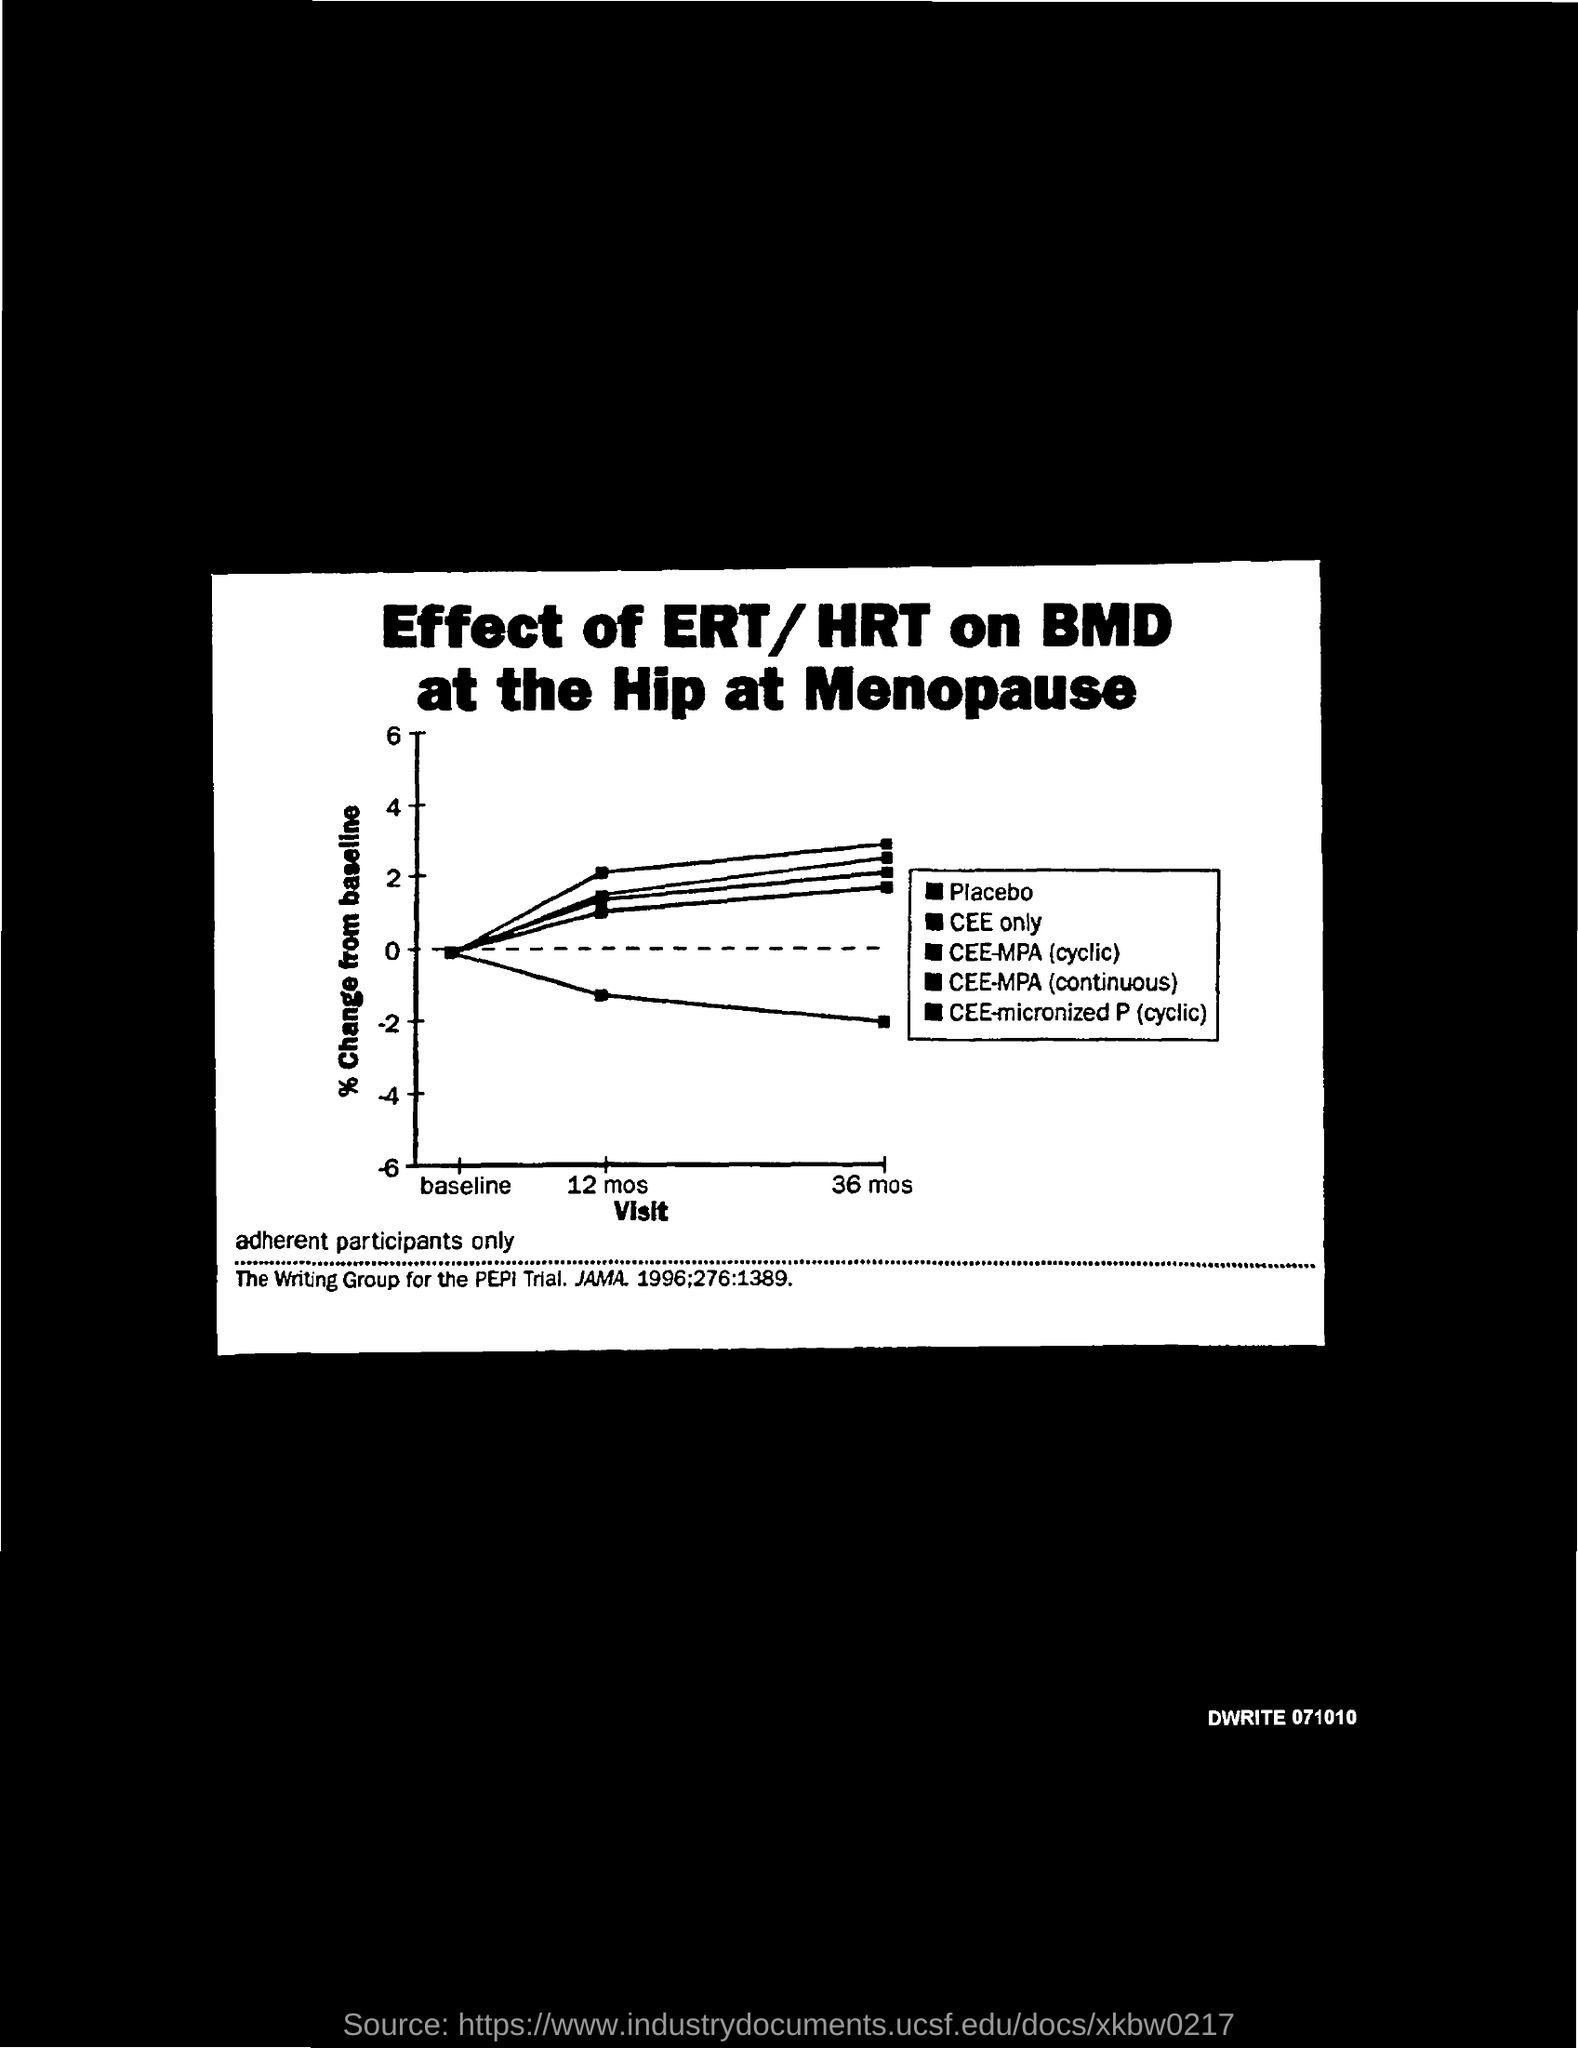What is the Document Number?
Your answer should be compact. DWRITE 071010. 